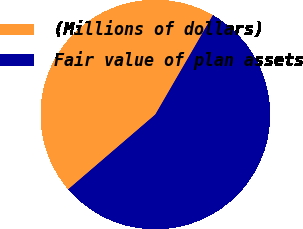Convert chart to OTSL. <chart><loc_0><loc_0><loc_500><loc_500><pie_chart><fcel>(Millions of dollars)<fcel>Fair value of plan assets<nl><fcel>44.65%<fcel>55.35%<nl></chart> 